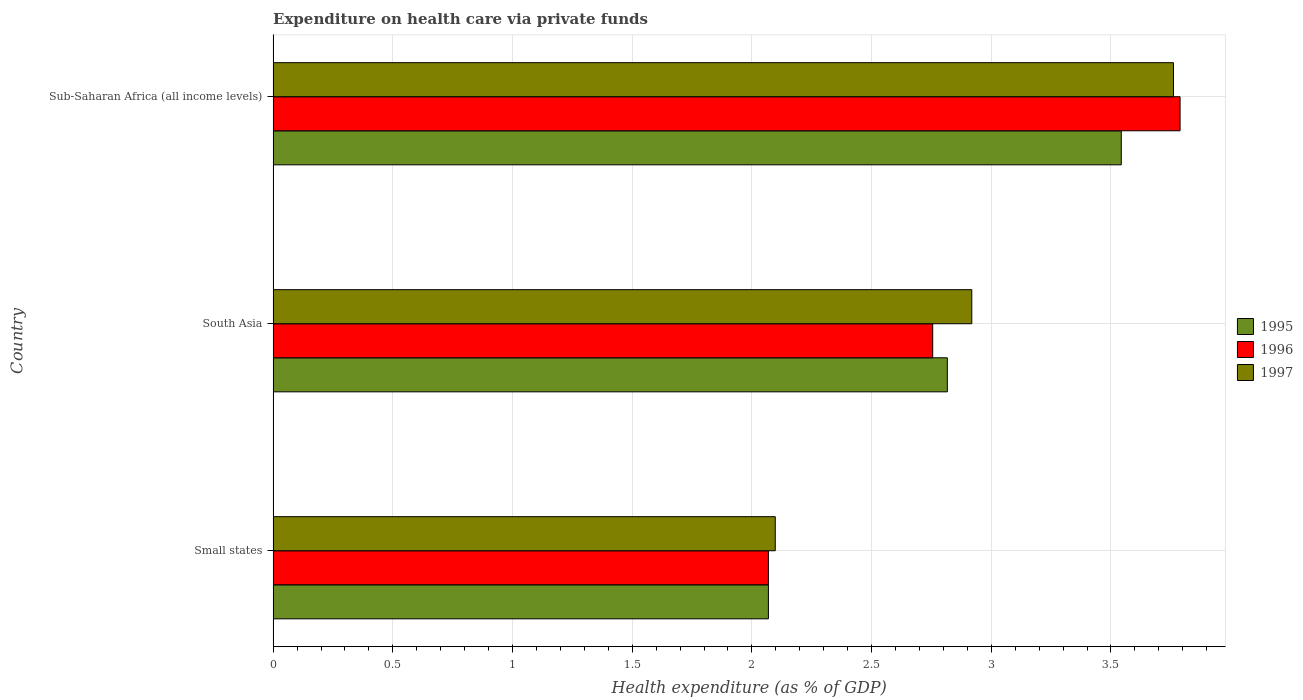How many different coloured bars are there?
Your answer should be compact. 3. Are the number of bars on each tick of the Y-axis equal?
Make the answer very short. Yes. How many bars are there on the 2nd tick from the top?
Offer a terse response. 3. What is the label of the 3rd group of bars from the top?
Your response must be concise. Small states. What is the expenditure made on health care in 1997 in South Asia?
Make the answer very short. 2.92. Across all countries, what is the maximum expenditure made on health care in 1995?
Keep it short and to the point. 3.54. Across all countries, what is the minimum expenditure made on health care in 1997?
Your answer should be very brief. 2.1. In which country was the expenditure made on health care in 1995 maximum?
Your response must be concise. Sub-Saharan Africa (all income levels). In which country was the expenditure made on health care in 1997 minimum?
Keep it short and to the point. Small states. What is the total expenditure made on health care in 1996 in the graph?
Your response must be concise. 8.61. What is the difference between the expenditure made on health care in 1996 in South Asia and that in Sub-Saharan Africa (all income levels)?
Your answer should be compact. -1.03. What is the difference between the expenditure made on health care in 1995 in South Asia and the expenditure made on health care in 1997 in Small states?
Your answer should be very brief. 0.72. What is the average expenditure made on health care in 1996 per country?
Ensure brevity in your answer.  2.87. What is the difference between the expenditure made on health care in 1995 and expenditure made on health care in 1996 in Small states?
Provide a succinct answer. -2.144116155022857e-5. What is the ratio of the expenditure made on health care in 1997 in Small states to that in South Asia?
Your response must be concise. 0.72. Is the expenditure made on health care in 1996 in South Asia less than that in Sub-Saharan Africa (all income levels)?
Ensure brevity in your answer.  Yes. What is the difference between the highest and the second highest expenditure made on health care in 1997?
Provide a succinct answer. 0.84. What is the difference between the highest and the lowest expenditure made on health care in 1996?
Give a very brief answer. 1.72. Is the sum of the expenditure made on health care in 1996 in Small states and South Asia greater than the maximum expenditure made on health care in 1995 across all countries?
Provide a succinct answer. Yes. Is it the case that in every country, the sum of the expenditure made on health care in 1996 and expenditure made on health care in 1997 is greater than the expenditure made on health care in 1995?
Offer a very short reply. Yes. How many bars are there?
Make the answer very short. 9. Are all the bars in the graph horizontal?
Your response must be concise. Yes. How many countries are there in the graph?
Keep it short and to the point. 3. What is the difference between two consecutive major ticks on the X-axis?
Offer a terse response. 0.5. Does the graph contain grids?
Offer a terse response. Yes. How are the legend labels stacked?
Offer a very short reply. Vertical. What is the title of the graph?
Provide a short and direct response. Expenditure on health care via private funds. Does "1965" appear as one of the legend labels in the graph?
Keep it short and to the point. No. What is the label or title of the X-axis?
Provide a succinct answer. Health expenditure (as % of GDP). What is the Health expenditure (as % of GDP) of 1995 in Small states?
Provide a succinct answer. 2.07. What is the Health expenditure (as % of GDP) of 1996 in Small states?
Provide a succinct answer. 2.07. What is the Health expenditure (as % of GDP) in 1997 in Small states?
Provide a succinct answer. 2.1. What is the Health expenditure (as % of GDP) of 1995 in South Asia?
Your answer should be compact. 2.82. What is the Health expenditure (as % of GDP) of 1996 in South Asia?
Make the answer very short. 2.76. What is the Health expenditure (as % of GDP) in 1997 in South Asia?
Offer a very short reply. 2.92. What is the Health expenditure (as % of GDP) of 1995 in Sub-Saharan Africa (all income levels)?
Your answer should be very brief. 3.54. What is the Health expenditure (as % of GDP) in 1996 in Sub-Saharan Africa (all income levels)?
Provide a short and direct response. 3.79. What is the Health expenditure (as % of GDP) in 1997 in Sub-Saharan Africa (all income levels)?
Provide a short and direct response. 3.76. Across all countries, what is the maximum Health expenditure (as % of GDP) in 1995?
Make the answer very short. 3.54. Across all countries, what is the maximum Health expenditure (as % of GDP) in 1996?
Give a very brief answer. 3.79. Across all countries, what is the maximum Health expenditure (as % of GDP) in 1997?
Your answer should be compact. 3.76. Across all countries, what is the minimum Health expenditure (as % of GDP) of 1995?
Offer a terse response. 2.07. Across all countries, what is the minimum Health expenditure (as % of GDP) of 1996?
Give a very brief answer. 2.07. Across all countries, what is the minimum Health expenditure (as % of GDP) in 1997?
Offer a very short reply. 2.1. What is the total Health expenditure (as % of GDP) in 1995 in the graph?
Provide a short and direct response. 8.43. What is the total Health expenditure (as % of GDP) of 1996 in the graph?
Provide a succinct answer. 8.61. What is the total Health expenditure (as % of GDP) in 1997 in the graph?
Give a very brief answer. 8.78. What is the difference between the Health expenditure (as % of GDP) in 1995 in Small states and that in South Asia?
Provide a short and direct response. -0.75. What is the difference between the Health expenditure (as % of GDP) of 1996 in Small states and that in South Asia?
Offer a terse response. -0.69. What is the difference between the Health expenditure (as % of GDP) of 1997 in Small states and that in South Asia?
Ensure brevity in your answer.  -0.82. What is the difference between the Health expenditure (as % of GDP) of 1995 in Small states and that in Sub-Saharan Africa (all income levels)?
Keep it short and to the point. -1.47. What is the difference between the Health expenditure (as % of GDP) of 1996 in Small states and that in Sub-Saharan Africa (all income levels)?
Your answer should be very brief. -1.72. What is the difference between the Health expenditure (as % of GDP) in 1997 in Small states and that in Sub-Saharan Africa (all income levels)?
Offer a very short reply. -1.66. What is the difference between the Health expenditure (as % of GDP) of 1995 in South Asia and that in Sub-Saharan Africa (all income levels)?
Your response must be concise. -0.73. What is the difference between the Health expenditure (as % of GDP) of 1996 in South Asia and that in Sub-Saharan Africa (all income levels)?
Offer a terse response. -1.03. What is the difference between the Health expenditure (as % of GDP) in 1997 in South Asia and that in Sub-Saharan Africa (all income levels)?
Your answer should be compact. -0.84. What is the difference between the Health expenditure (as % of GDP) of 1995 in Small states and the Health expenditure (as % of GDP) of 1996 in South Asia?
Give a very brief answer. -0.69. What is the difference between the Health expenditure (as % of GDP) of 1995 in Small states and the Health expenditure (as % of GDP) of 1997 in South Asia?
Your answer should be compact. -0.85. What is the difference between the Health expenditure (as % of GDP) in 1996 in Small states and the Health expenditure (as % of GDP) in 1997 in South Asia?
Provide a short and direct response. -0.85. What is the difference between the Health expenditure (as % of GDP) of 1995 in Small states and the Health expenditure (as % of GDP) of 1996 in Sub-Saharan Africa (all income levels)?
Offer a very short reply. -1.72. What is the difference between the Health expenditure (as % of GDP) in 1995 in Small states and the Health expenditure (as % of GDP) in 1997 in Sub-Saharan Africa (all income levels)?
Ensure brevity in your answer.  -1.69. What is the difference between the Health expenditure (as % of GDP) in 1996 in Small states and the Health expenditure (as % of GDP) in 1997 in Sub-Saharan Africa (all income levels)?
Provide a succinct answer. -1.69. What is the difference between the Health expenditure (as % of GDP) of 1995 in South Asia and the Health expenditure (as % of GDP) of 1996 in Sub-Saharan Africa (all income levels)?
Your answer should be very brief. -0.97. What is the difference between the Health expenditure (as % of GDP) of 1995 in South Asia and the Health expenditure (as % of GDP) of 1997 in Sub-Saharan Africa (all income levels)?
Make the answer very short. -0.94. What is the difference between the Health expenditure (as % of GDP) in 1996 in South Asia and the Health expenditure (as % of GDP) in 1997 in Sub-Saharan Africa (all income levels)?
Offer a very short reply. -1.01. What is the average Health expenditure (as % of GDP) of 1995 per country?
Offer a very short reply. 2.81. What is the average Health expenditure (as % of GDP) of 1996 per country?
Offer a terse response. 2.87. What is the average Health expenditure (as % of GDP) in 1997 per country?
Offer a very short reply. 2.93. What is the difference between the Health expenditure (as % of GDP) in 1995 and Health expenditure (as % of GDP) in 1996 in Small states?
Ensure brevity in your answer.  -0. What is the difference between the Health expenditure (as % of GDP) of 1995 and Health expenditure (as % of GDP) of 1997 in Small states?
Provide a succinct answer. -0.03. What is the difference between the Health expenditure (as % of GDP) in 1996 and Health expenditure (as % of GDP) in 1997 in Small states?
Provide a short and direct response. -0.03. What is the difference between the Health expenditure (as % of GDP) in 1995 and Health expenditure (as % of GDP) in 1996 in South Asia?
Give a very brief answer. 0.06. What is the difference between the Health expenditure (as % of GDP) in 1995 and Health expenditure (as % of GDP) in 1997 in South Asia?
Provide a short and direct response. -0.1. What is the difference between the Health expenditure (as % of GDP) of 1996 and Health expenditure (as % of GDP) of 1997 in South Asia?
Make the answer very short. -0.16. What is the difference between the Health expenditure (as % of GDP) of 1995 and Health expenditure (as % of GDP) of 1996 in Sub-Saharan Africa (all income levels)?
Give a very brief answer. -0.25. What is the difference between the Health expenditure (as % of GDP) in 1995 and Health expenditure (as % of GDP) in 1997 in Sub-Saharan Africa (all income levels)?
Offer a very short reply. -0.22. What is the difference between the Health expenditure (as % of GDP) of 1996 and Health expenditure (as % of GDP) of 1997 in Sub-Saharan Africa (all income levels)?
Provide a succinct answer. 0.03. What is the ratio of the Health expenditure (as % of GDP) of 1995 in Small states to that in South Asia?
Your answer should be compact. 0.73. What is the ratio of the Health expenditure (as % of GDP) in 1996 in Small states to that in South Asia?
Your response must be concise. 0.75. What is the ratio of the Health expenditure (as % of GDP) of 1997 in Small states to that in South Asia?
Your response must be concise. 0.72. What is the ratio of the Health expenditure (as % of GDP) of 1995 in Small states to that in Sub-Saharan Africa (all income levels)?
Your response must be concise. 0.58. What is the ratio of the Health expenditure (as % of GDP) of 1996 in Small states to that in Sub-Saharan Africa (all income levels)?
Offer a very short reply. 0.55. What is the ratio of the Health expenditure (as % of GDP) in 1997 in Small states to that in Sub-Saharan Africa (all income levels)?
Your answer should be very brief. 0.56. What is the ratio of the Health expenditure (as % of GDP) in 1995 in South Asia to that in Sub-Saharan Africa (all income levels)?
Your answer should be compact. 0.79. What is the ratio of the Health expenditure (as % of GDP) in 1996 in South Asia to that in Sub-Saharan Africa (all income levels)?
Offer a very short reply. 0.73. What is the ratio of the Health expenditure (as % of GDP) of 1997 in South Asia to that in Sub-Saharan Africa (all income levels)?
Give a very brief answer. 0.78. What is the difference between the highest and the second highest Health expenditure (as % of GDP) of 1995?
Offer a terse response. 0.73. What is the difference between the highest and the second highest Health expenditure (as % of GDP) in 1996?
Your answer should be compact. 1.03. What is the difference between the highest and the second highest Health expenditure (as % of GDP) of 1997?
Provide a succinct answer. 0.84. What is the difference between the highest and the lowest Health expenditure (as % of GDP) in 1995?
Offer a terse response. 1.47. What is the difference between the highest and the lowest Health expenditure (as % of GDP) of 1996?
Offer a terse response. 1.72. What is the difference between the highest and the lowest Health expenditure (as % of GDP) of 1997?
Make the answer very short. 1.66. 